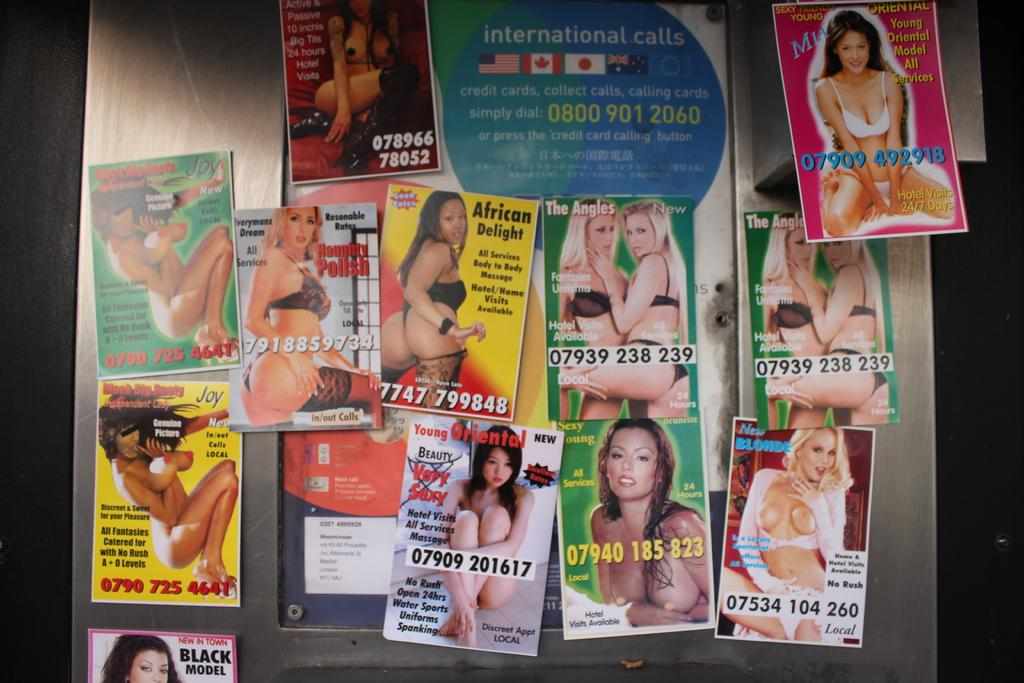What type of reading material is present in the image? There are magazines in the image. What can be found within the pages of these magazines? The magazines contain pictures of women. What type of boat is featured in the skirt of the woman in the image? There is no boat or skirt present in the image; it only contains magazines with pictures of women. 